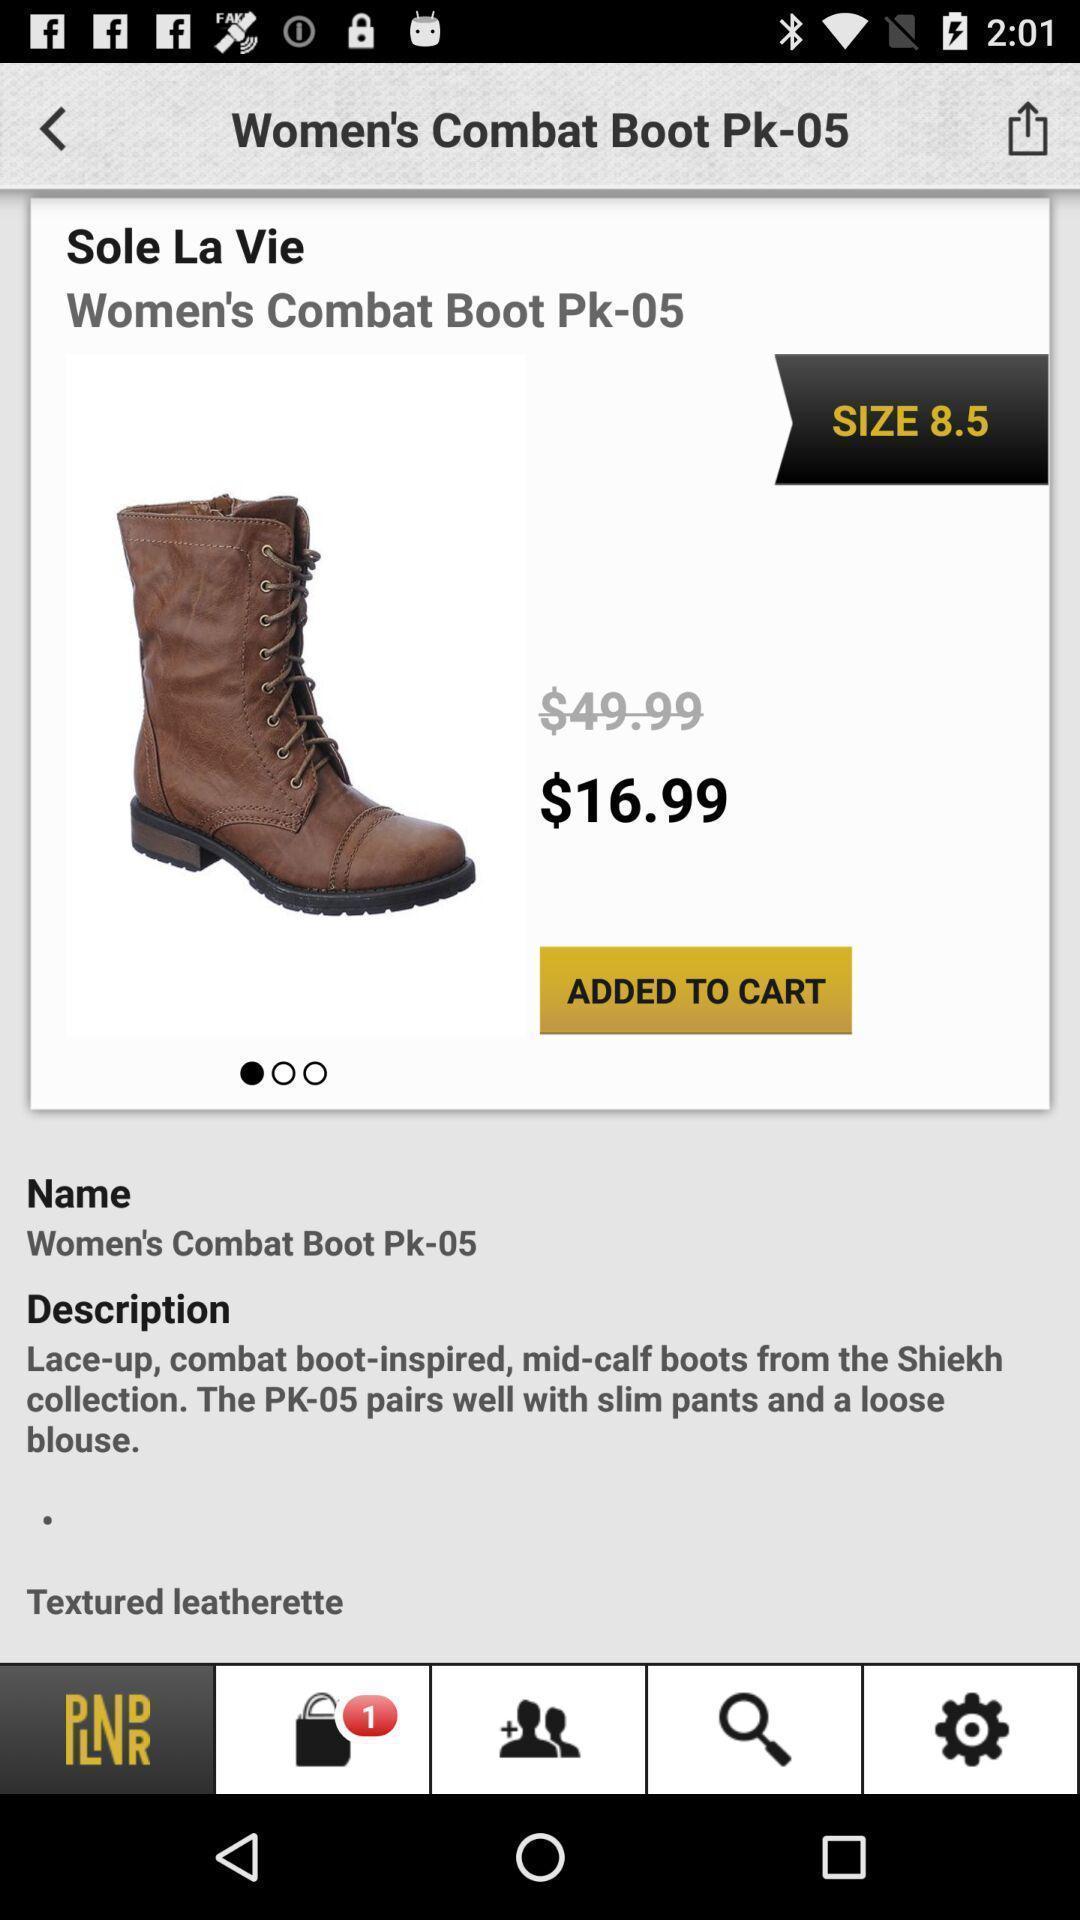Explain the elements present in this screenshot. Shopping app displayed an item with price. 